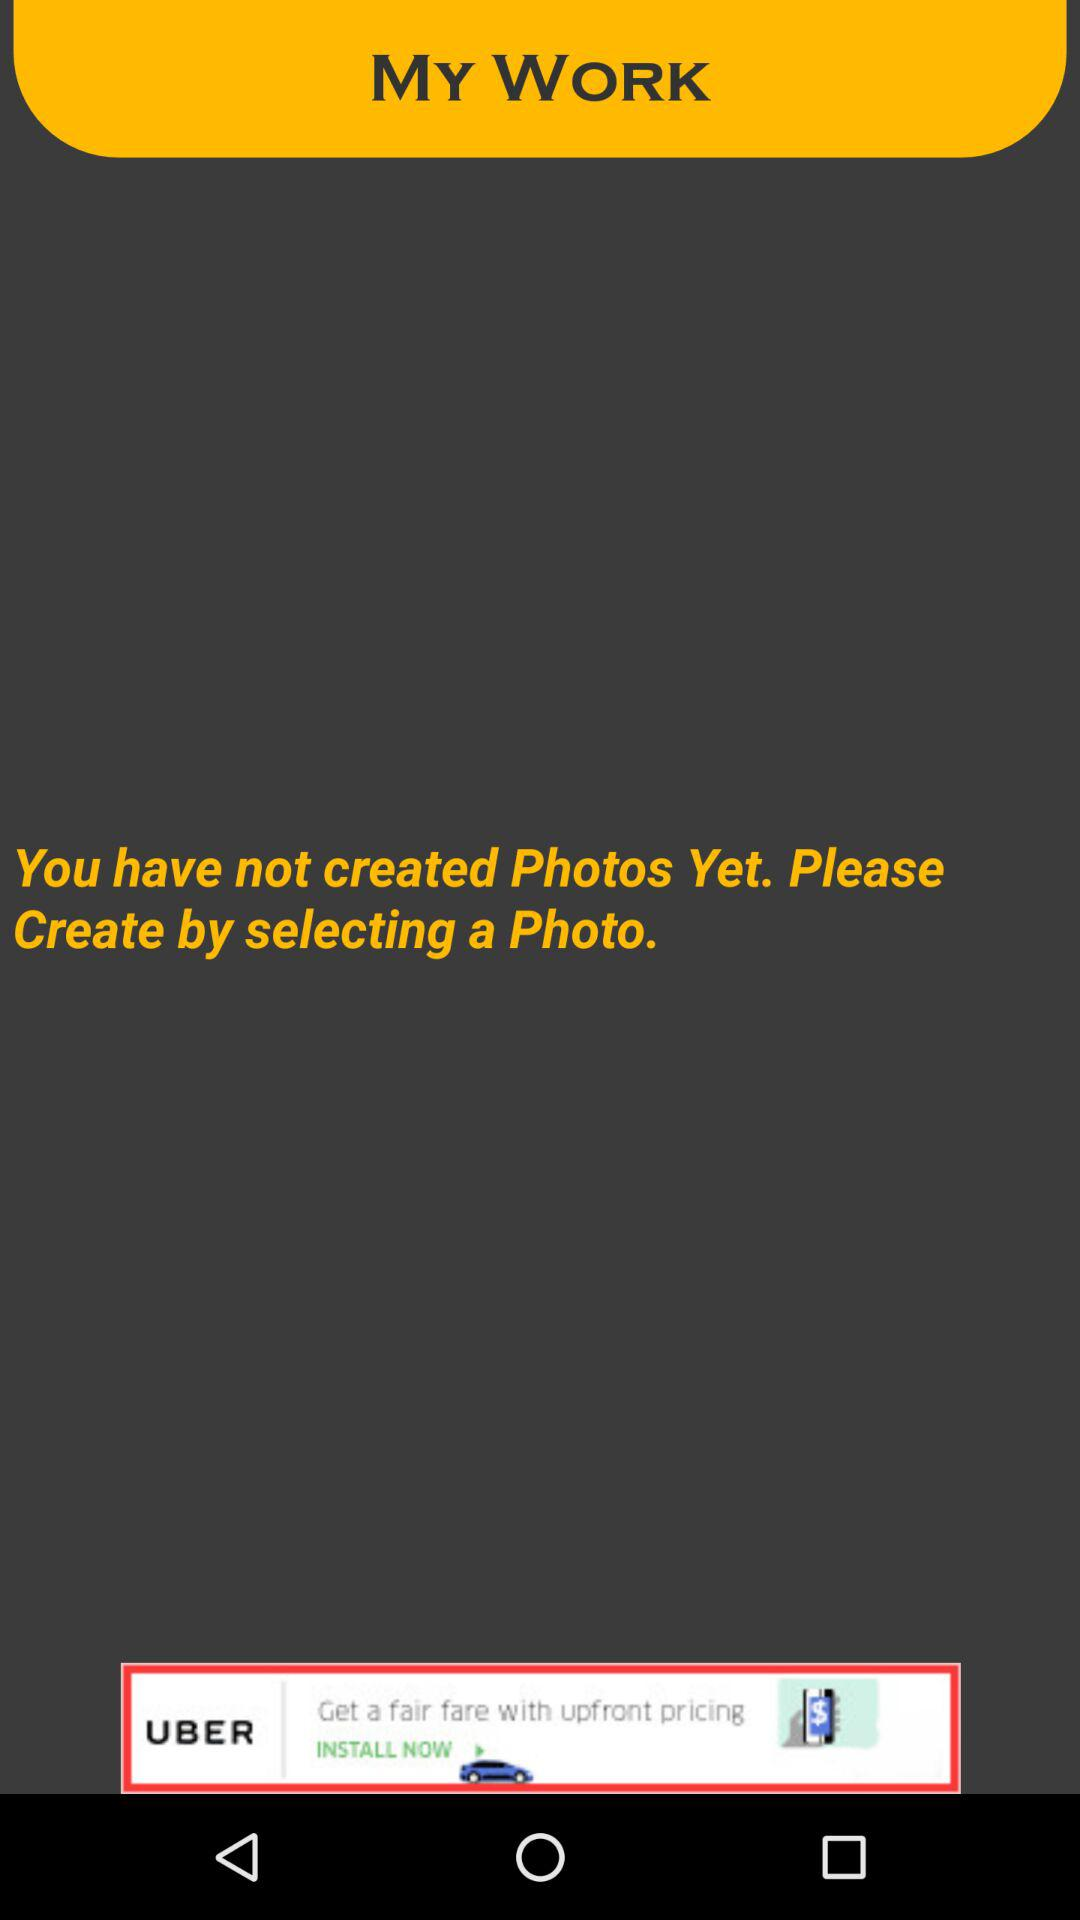Is there any photo created?
When the provided information is insufficient, respond with <no answer>. <no answer> 